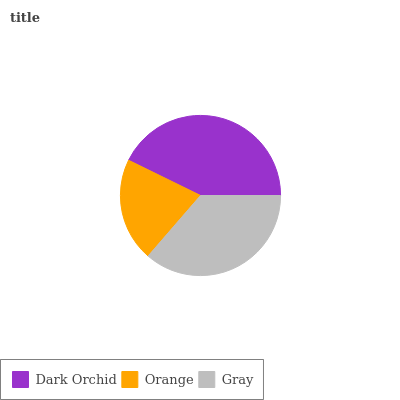Is Orange the minimum?
Answer yes or no. Yes. Is Dark Orchid the maximum?
Answer yes or no. Yes. Is Gray the minimum?
Answer yes or no. No. Is Gray the maximum?
Answer yes or no. No. Is Gray greater than Orange?
Answer yes or no. Yes. Is Orange less than Gray?
Answer yes or no. Yes. Is Orange greater than Gray?
Answer yes or no. No. Is Gray less than Orange?
Answer yes or no. No. Is Gray the high median?
Answer yes or no. Yes. Is Gray the low median?
Answer yes or no. Yes. Is Dark Orchid the high median?
Answer yes or no. No. Is Dark Orchid the low median?
Answer yes or no. No. 